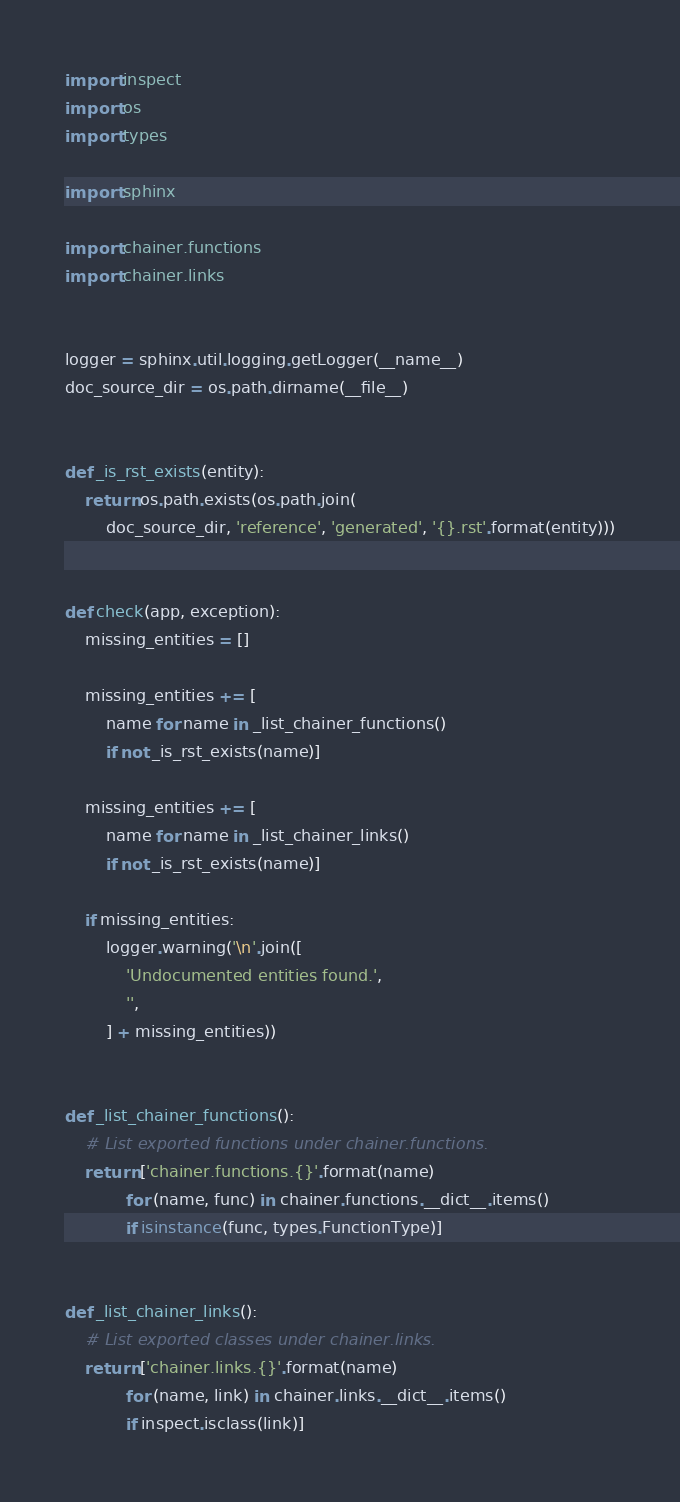<code> <loc_0><loc_0><loc_500><loc_500><_Python_>import inspect
import os
import types

import sphinx

import chainer.functions
import chainer.links


logger = sphinx.util.logging.getLogger(__name__)
doc_source_dir = os.path.dirname(__file__)


def _is_rst_exists(entity):
    return os.path.exists(os.path.join(
        doc_source_dir, 'reference', 'generated', '{}.rst'.format(entity)))


def check(app, exception):
    missing_entities = []

    missing_entities += [
        name for name in _list_chainer_functions()
        if not _is_rst_exists(name)]

    missing_entities += [
        name for name in _list_chainer_links()
        if not _is_rst_exists(name)]

    if missing_entities:
        logger.warning('\n'.join([
            'Undocumented entities found.',
            '',
        ] + missing_entities))


def _list_chainer_functions():
    # List exported functions under chainer.functions.
    return ['chainer.functions.{}'.format(name)
            for (name, func) in chainer.functions.__dict__.items()
            if isinstance(func, types.FunctionType)]


def _list_chainer_links():
    # List exported classes under chainer.links.
    return ['chainer.links.{}'.format(name)
            for (name, link) in chainer.links.__dict__.items()
            if inspect.isclass(link)]
</code> 